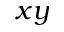Convert formula to latex. <formula><loc_0><loc_0><loc_500><loc_500>x y</formula> 